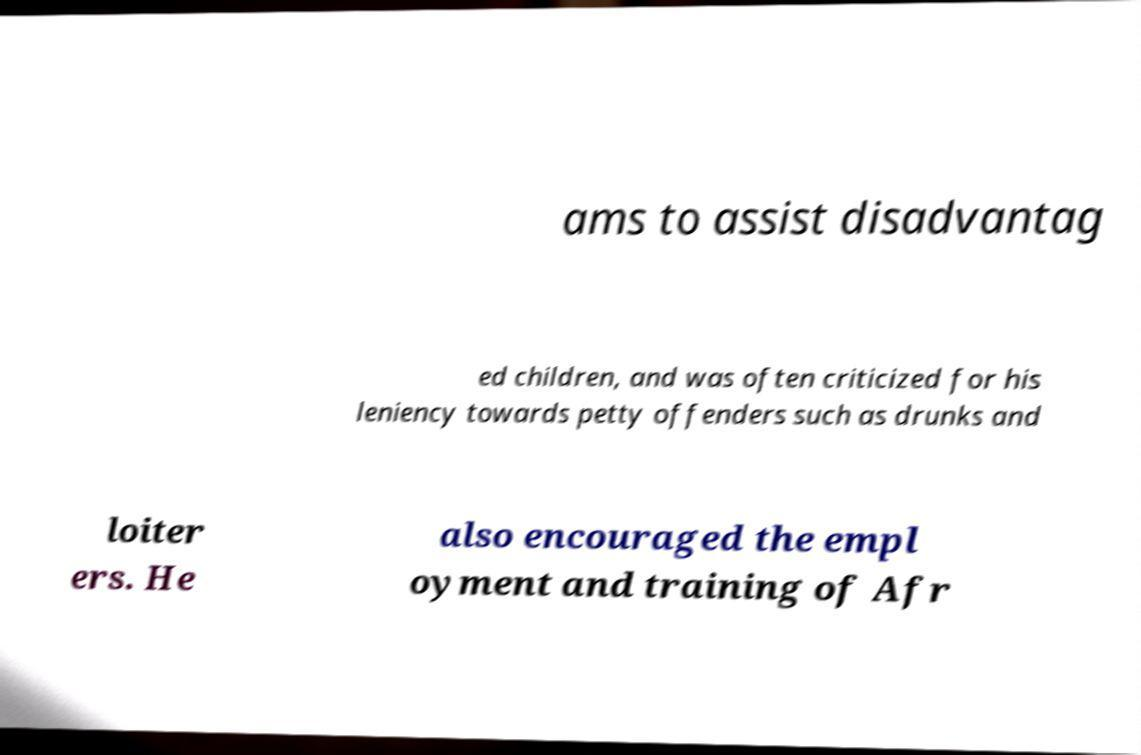Can you accurately transcribe the text from the provided image for me? ams to assist disadvantag ed children, and was often criticized for his leniency towards petty offenders such as drunks and loiter ers. He also encouraged the empl oyment and training of Afr 